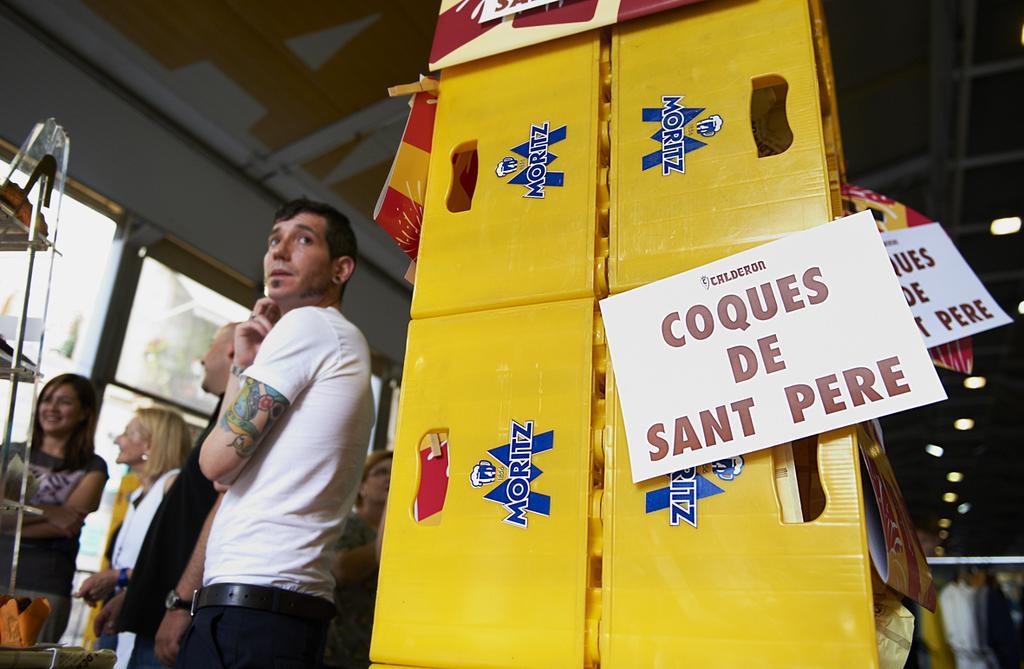Can you describe this image briefly? In the picture I can see big board to it we can see some papers are sicked,beside we can see some people are standing in front of the glass stand. 